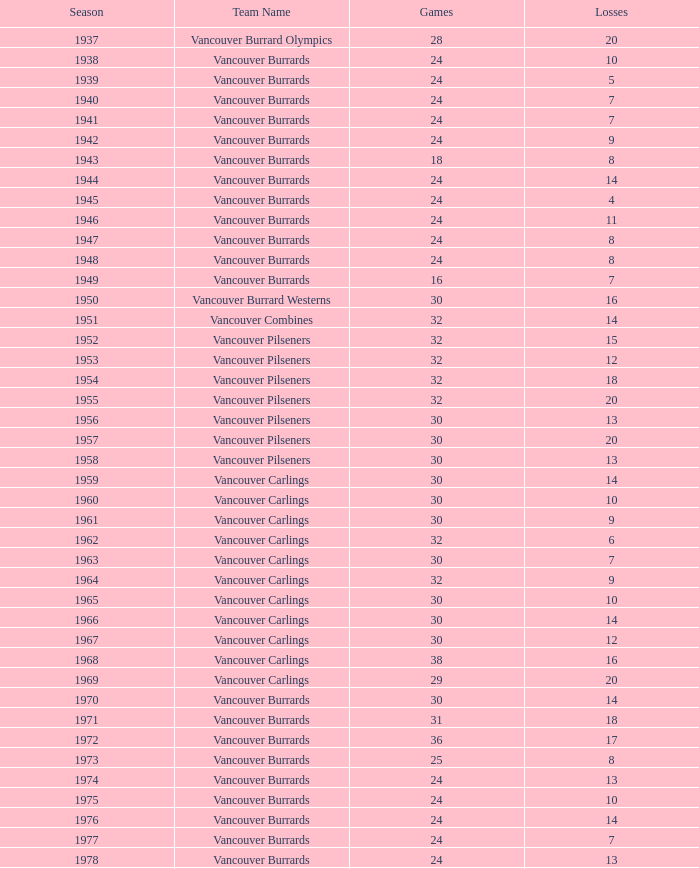With fewer than 8 losses and fewer than 24 games played, what is the least amount of points the vancouver burrards can achieve? 18.0. 